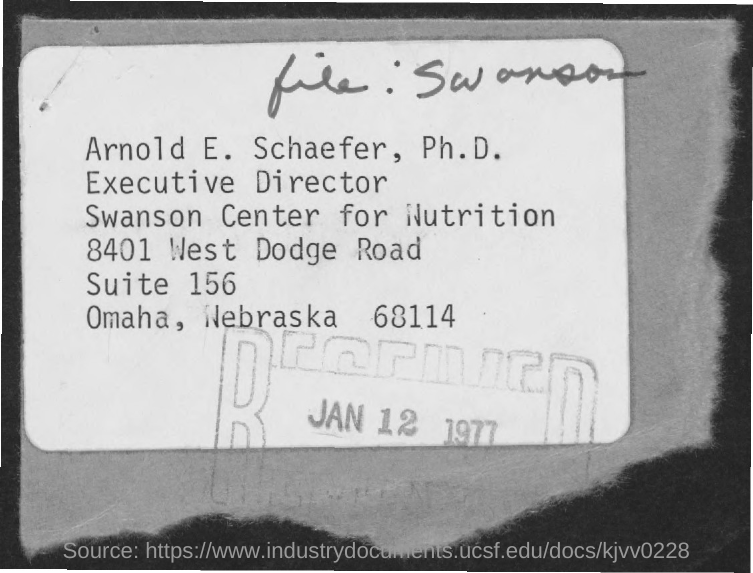Draw attention to some important aspects in this diagram. What is the number of West Dodge Road? It is 8401.. The number of suite is 156. The date on the stamp is January 12, 1977. The pincode of Omaha, Nebraska is 68114. 